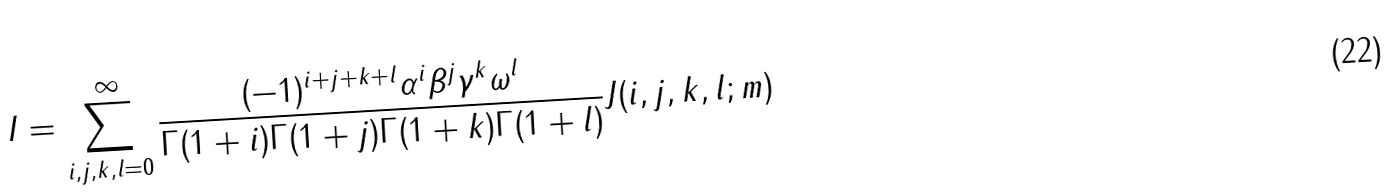<formula> <loc_0><loc_0><loc_500><loc_500>I = \sum _ { i , j , k , l = 0 } ^ { \infty } \frac { ( - 1 ) ^ { i + j + k + l } \alpha ^ { i } \beta ^ { j } \gamma ^ { k } \omega ^ { l } } { \Gamma ( 1 + i ) \Gamma ( 1 + j ) \Gamma ( 1 + k ) \Gamma ( 1 + l ) } J ( i , j , k , l ; m )</formula> 